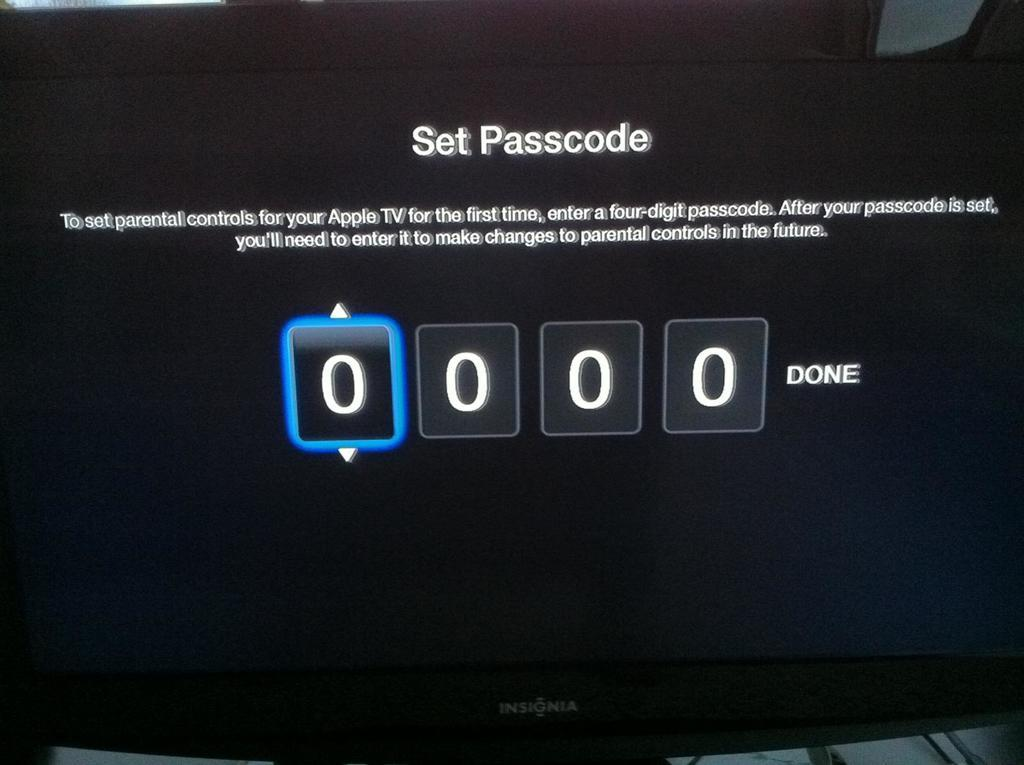What type of furniture is present in the image? There is a desktop in the image. What can be seen on the desktop? There is some text visible on the desktop. How does the desktop interact with the rain in the image? There is no rain present in the image, so the desktop does not interact with rain. 